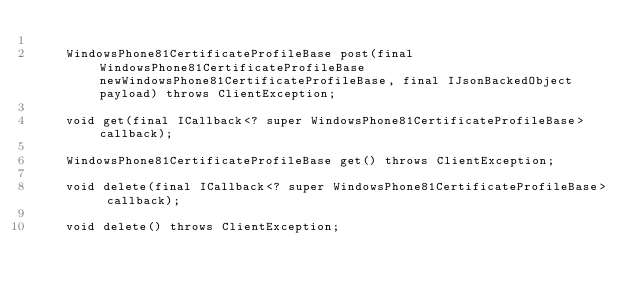<code> <loc_0><loc_0><loc_500><loc_500><_Java_>
    WindowsPhone81CertificateProfileBase post(final WindowsPhone81CertificateProfileBase newWindowsPhone81CertificateProfileBase, final IJsonBackedObject payload) throws ClientException;

    void get(final ICallback<? super WindowsPhone81CertificateProfileBase> callback);

    WindowsPhone81CertificateProfileBase get() throws ClientException;

	void delete(final ICallback<? super WindowsPhone81CertificateProfileBase> callback);

	void delete() throws ClientException;
</code> 